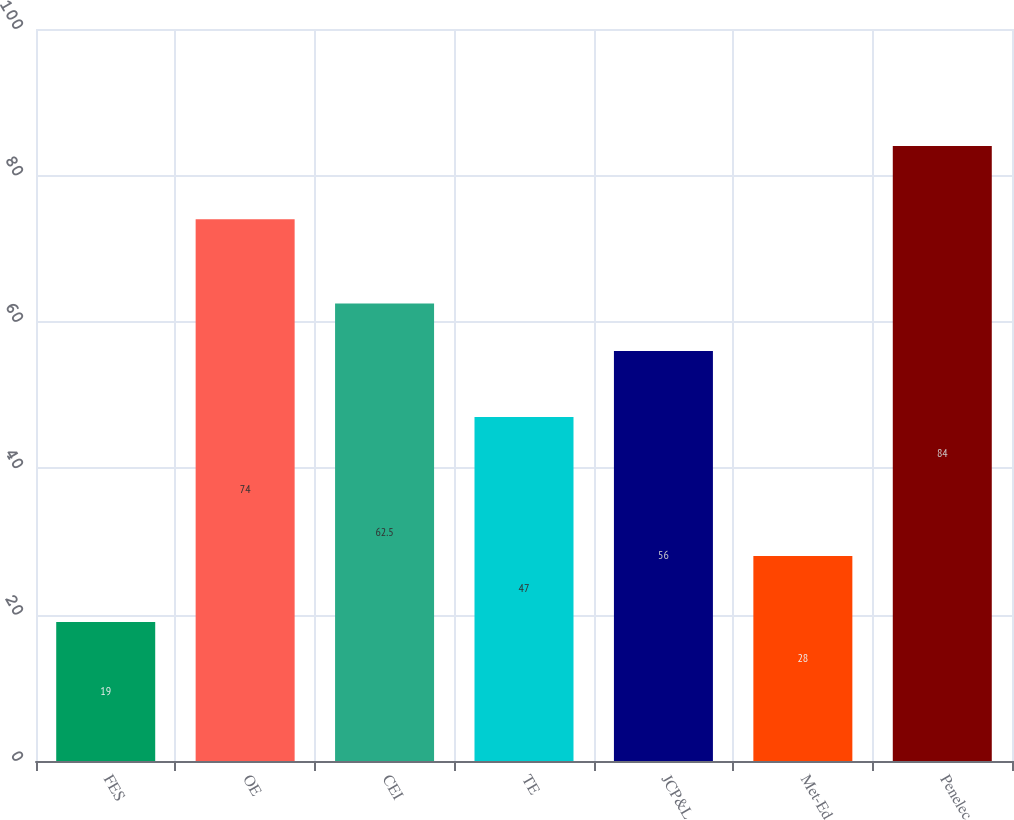Convert chart to OTSL. <chart><loc_0><loc_0><loc_500><loc_500><bar_chart><fcel>FES<fcel>OE<fcel>CEI<fcel>TE<fcel>JCP&L<fcel>Met-Ed<fcel>Penelec<nl><fcel>19<fcel>74<fcel>62.5<fcel>47<fcel>56<fcel>28<fcel>84<nl></chart> 